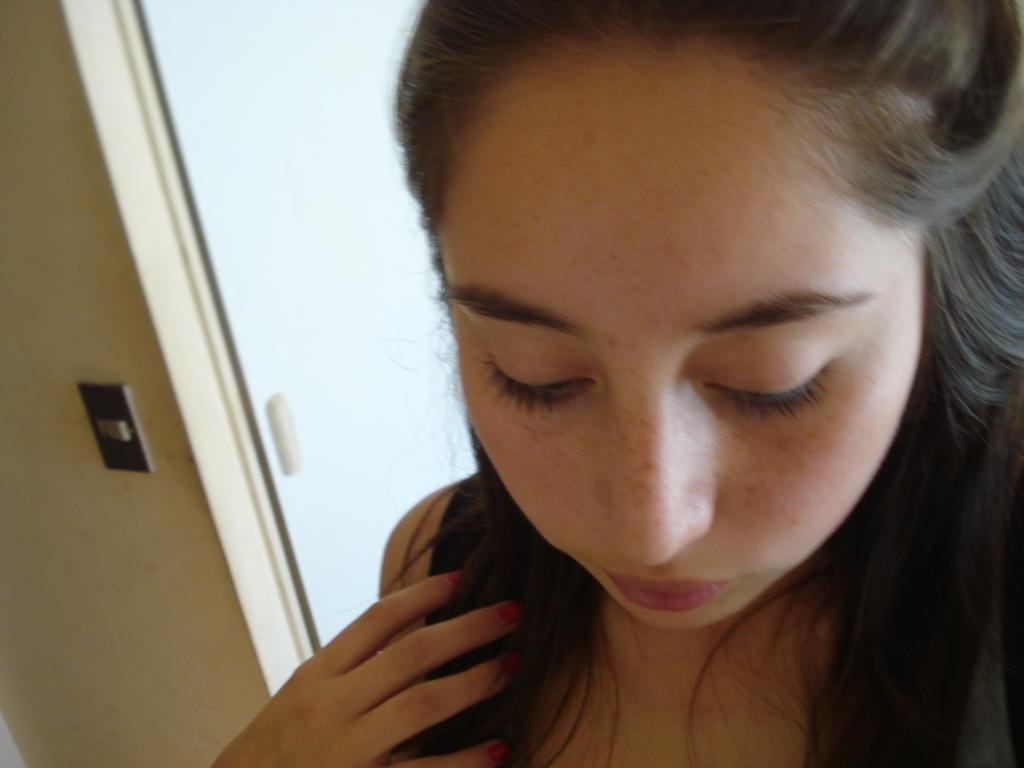Who is present in the image? There is a woman in the picture. What is the woman doing in the image? The woman is looking downwards. What can be seen behind the woman? There is a door behind the woman. What type of beef is being served on a plate in the image? There is no beef or plate present in the image; it only features a woman looking downwards and a door behind her. 